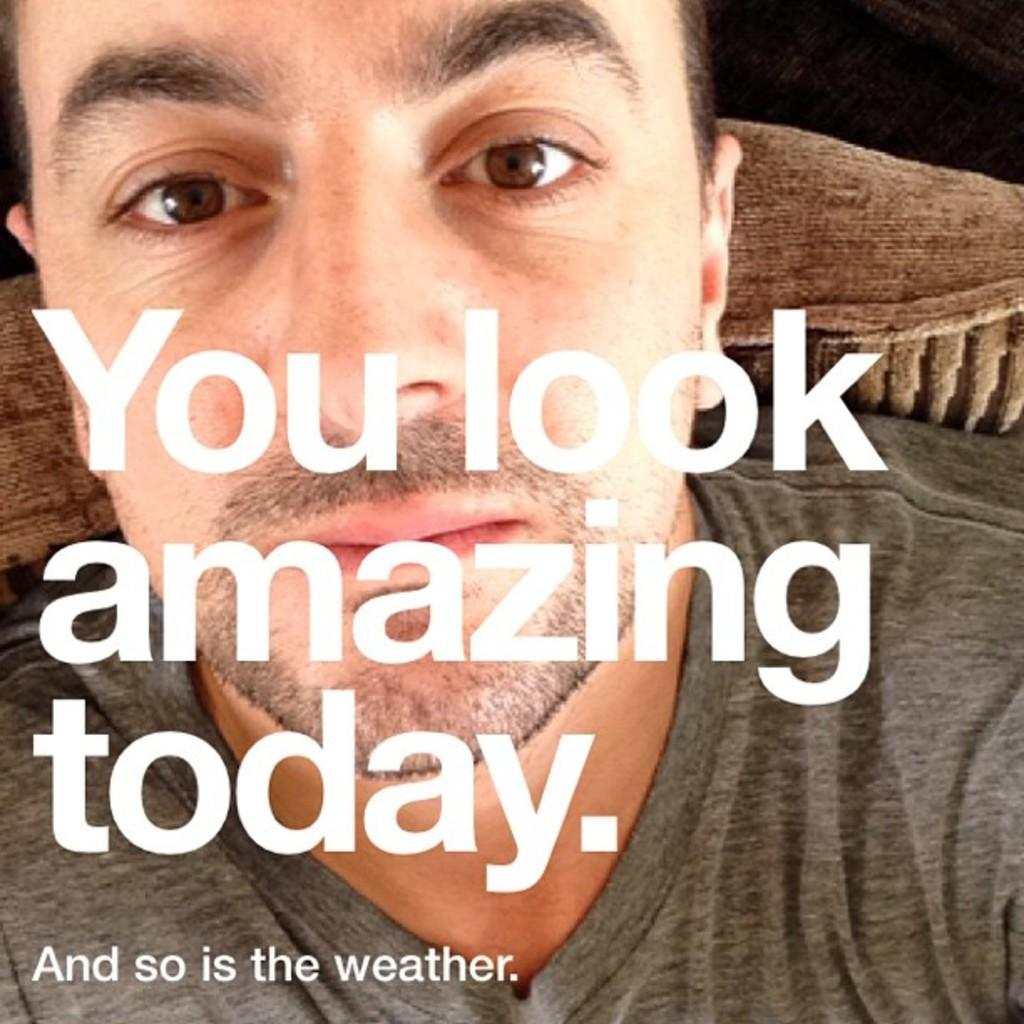What is featured in the image in the form of a printed material? There is a poster in the image. What is depicted on the poster? The poster contains an image of a man sitting on a couch. Are there any words on the poster? Yes, there is text on the poster. What type of detail can be seen on the floor in the image? There is no information about the floor or any details on it in the provided facts, so we cannot answer this question. 